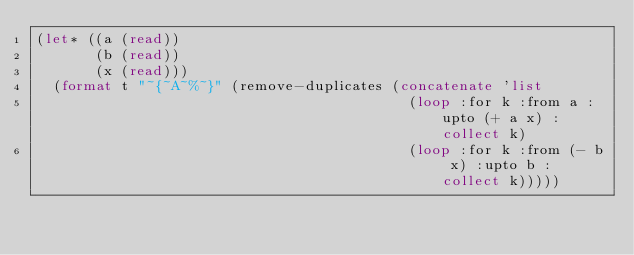Convert code to text. <code><loc_0><loc_0><loc_500><loc_500><_Lisp_>(let* ((a (read))
       (b (read))
       (x (read)))
  (format t "~{~A~%~}" (remove-duplicates (concatenate 'list
                                            (loop :for k :from a :upto (+ a x) :collect k)
                                            (loop :for k :from (- b x) :upto b :collect k)))))</code> 